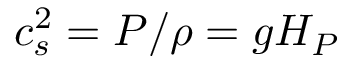<formula> <loc_0><loc_0><loc_500><loc_500>c _ { s } ^ { 2 } = P / \rho = g H _ { P }</formula> 